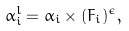Convert formula to latex. <formula><loc_0><loc_0><loc_500><loc_500>\alpha _ { i } ^ { l } = \alpha _ { i } \times ( F _ { i } ) ^ { \epsilon } ,</formula> 